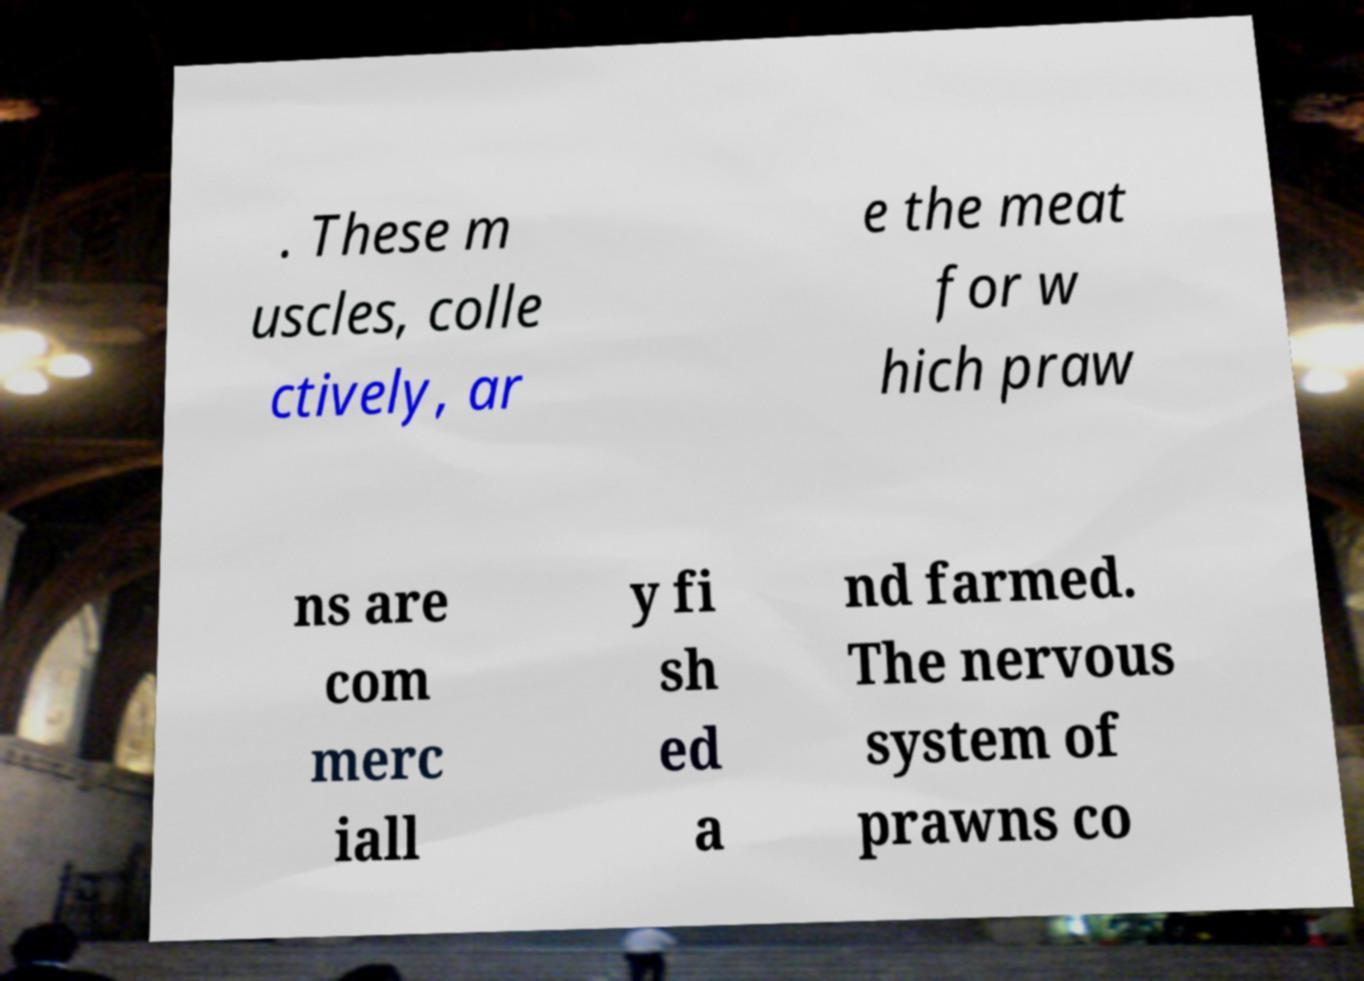I need the written content from this picture converted into text. Can you do that? . These m uscles, colle ctively, ar e the meat for w hich praw ns are com merc iall y fi sh ed a nd farmed. The nervous system of prawns co 